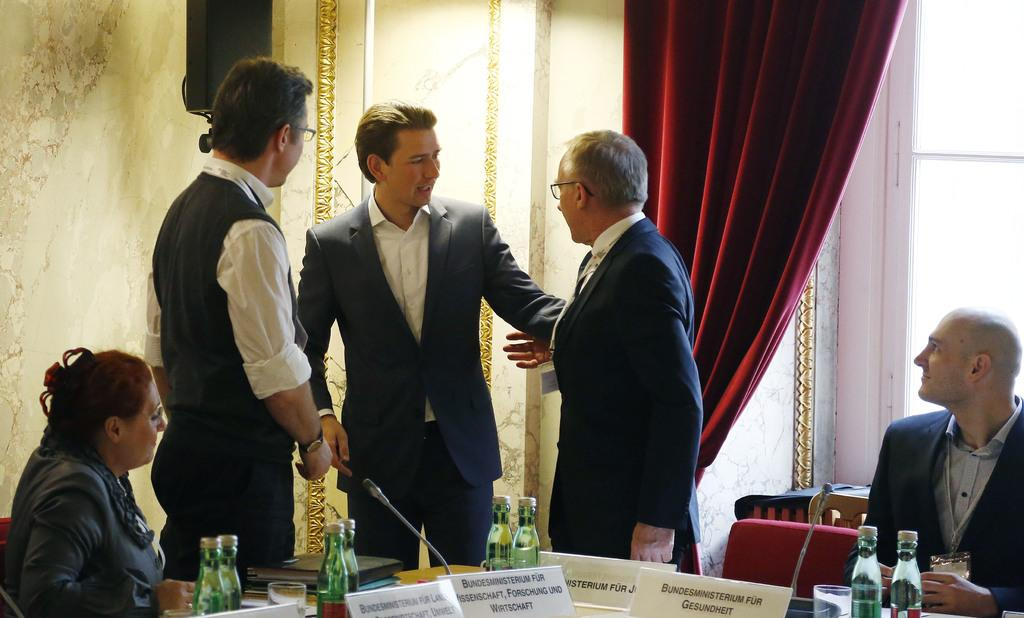How many people are present in the image? There are three persons standing and two persons sitting in the image, making a total of five people. What are the people doing in the image? The standing persons might be observing the sitting persons, but their exact actions are not clear. What objects can be seen on the table in the image? There are cards, bottles, and books on the table in the image. What color is the curtain in the image? There is a red curtain in the image. What type of canvas is being used for the painting in the image? There is no painting or canvas present in the image. How does the twist in the story affect the characters in the image? There is no story or twist mentioned in the image, as it only shows people, objects, and a red curtain. 